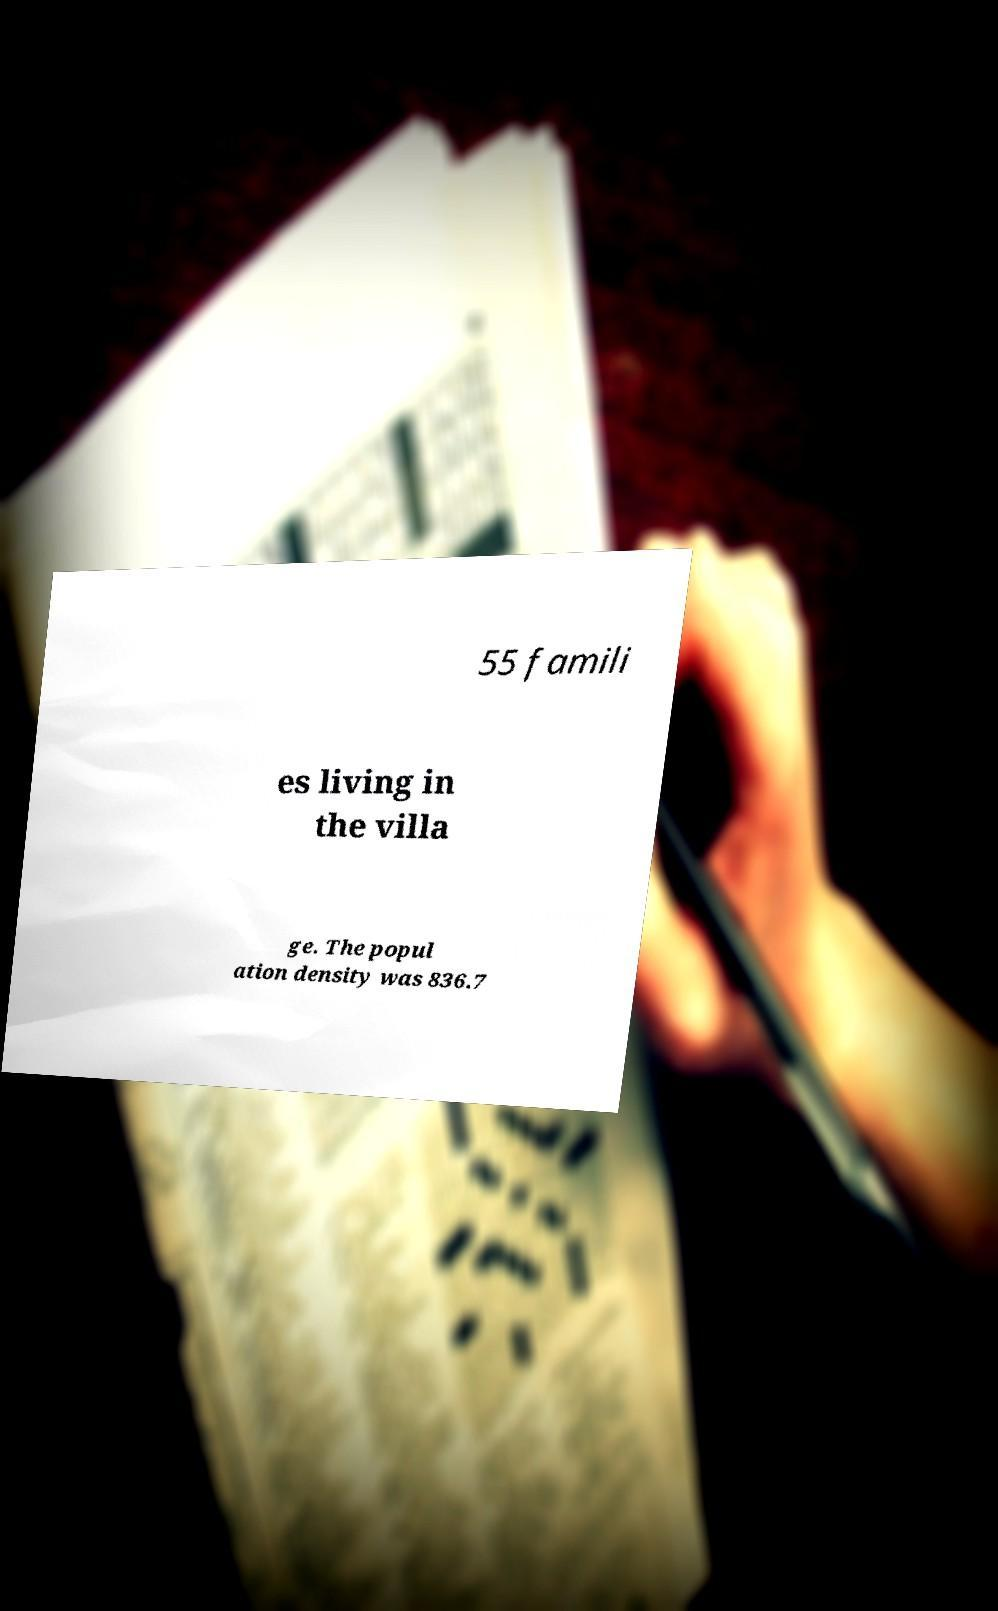There's text embedded in this image that I need extracted. Can you transcribe it verbatim? 55 famili es living in the villa ge. The popul ation density was 836.7 